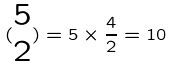<formula> <loc_0><loc_0><loc_500><loc_500>( \begin{matrix} 5 \\ 2 \end{matrix} ) = 5 \times \frac { 4 } { 2 } = 1 0</formula> 